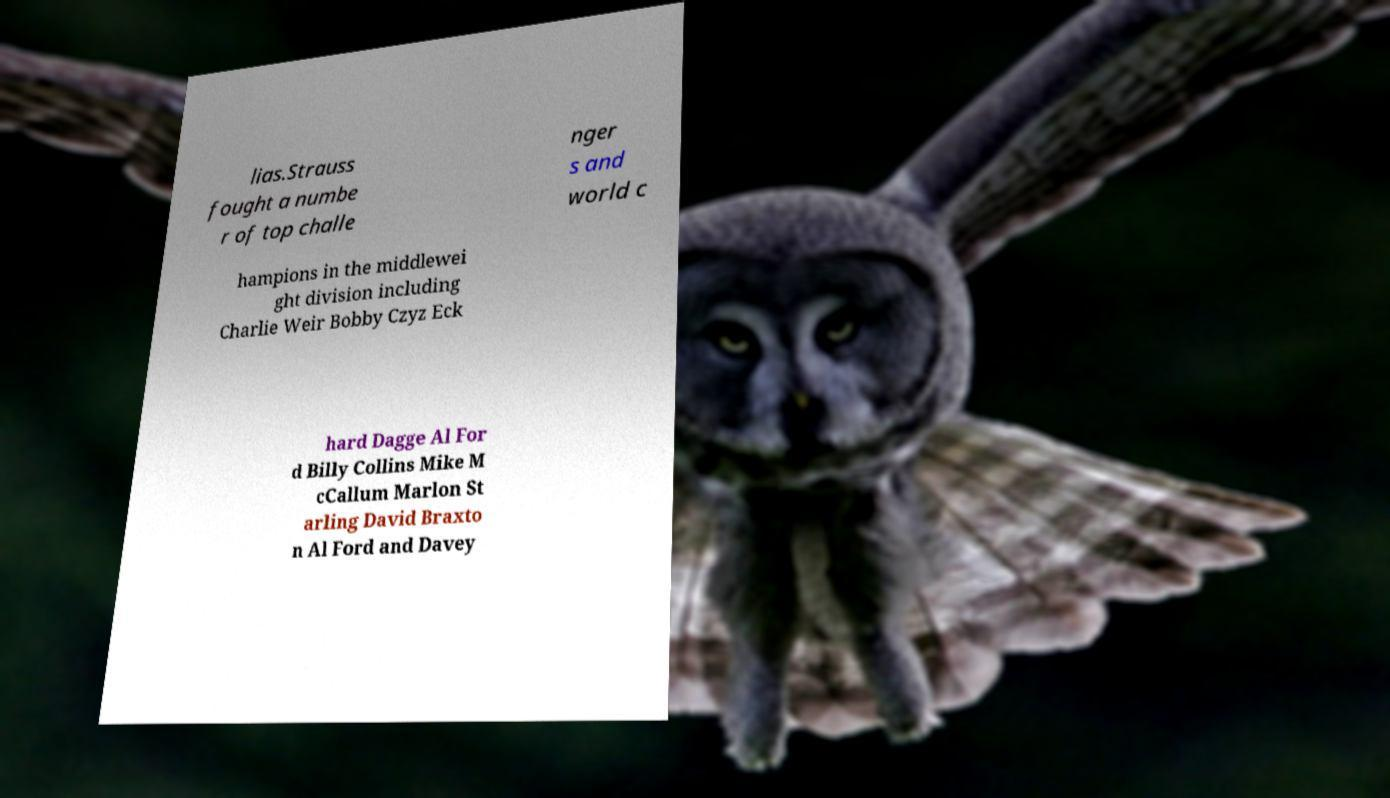What messages or text are displayed in this image? I need them in a readable, typed format. lias.Strauss fought a numbe r of top challe nger s and world c hampions in the middlewei ght division including Charlie Weir Bobby Czyz Eck hard Dagge Al For d Billy Collins Mike M cCallum Marlon St arling David Braxto n Al Ford and Davey 